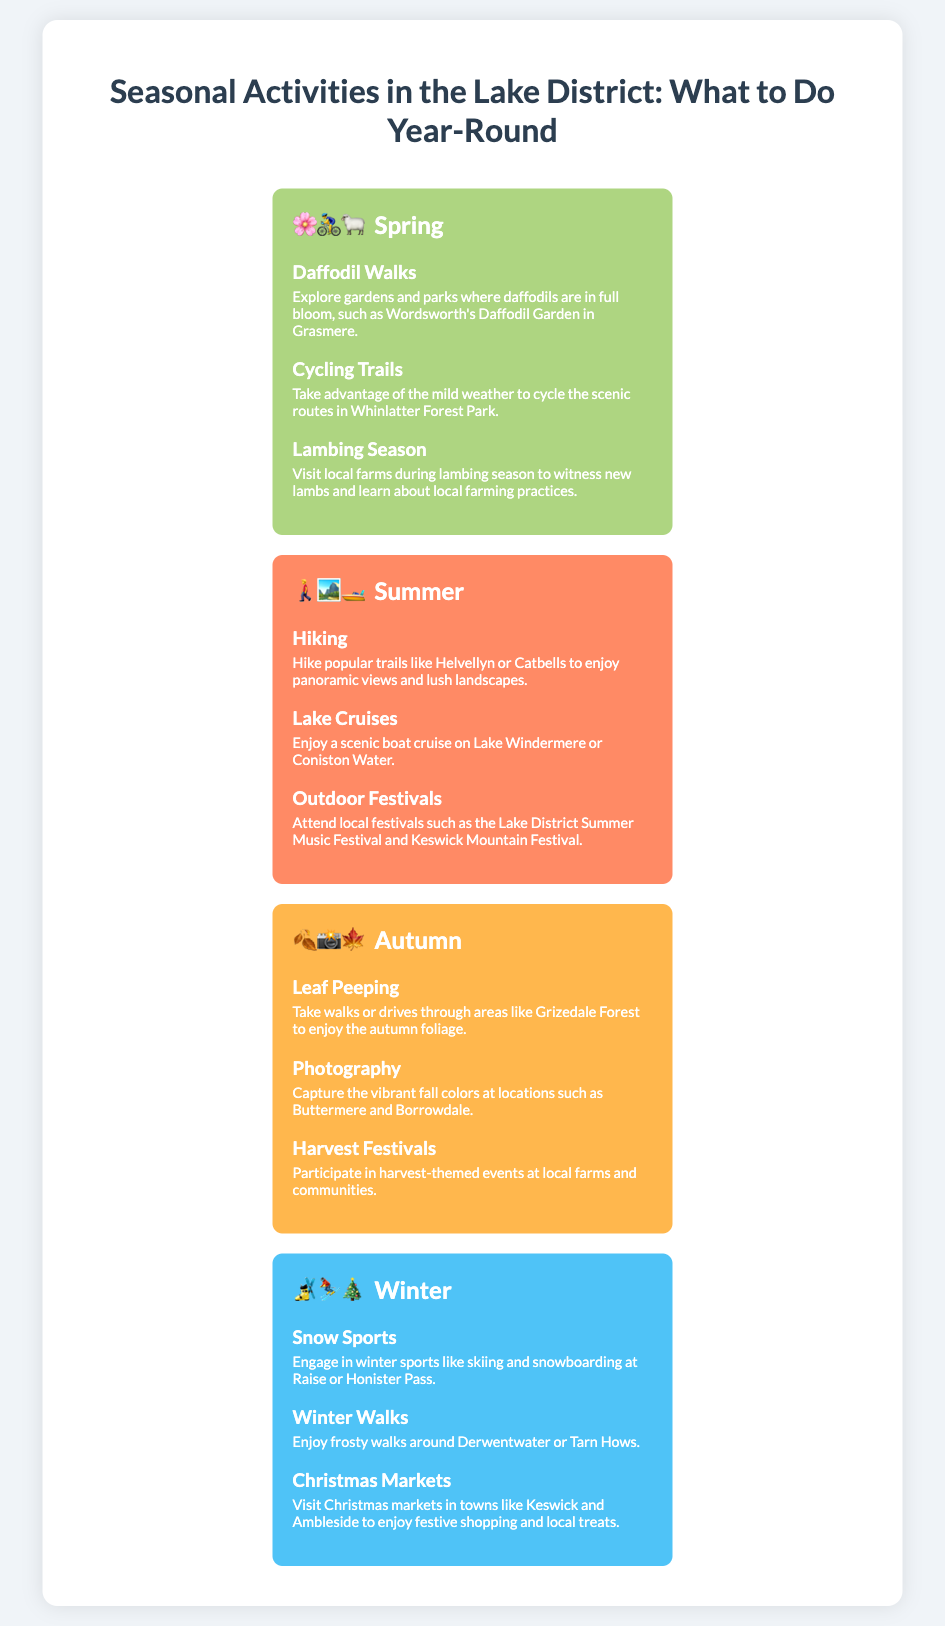What activities can you do in spring? The activities listed for spring include Daffodil Walks, Cycling Trails, and Lambing Season.
Answer: Daffodil Walks, Cycling Trails, Lambing Season Which season features hiking as an activity? Hiking is highlighted as an activity during the summer season.
Answer: Summer What color represents autumn in the infographic? The background color representing autumn is a shade of orange (#FFB74D).
Answer: Orange How many activities are listed for winter? There are three activities listed for winter: Snow Sports, Winter Walks, and Christmas Markets.
Answer: Three Which festival can you attend in summer? The activities mention attending the Lake District Summer Music Festival as a summer event.
Answer: Lake District Summer Music Festival What type of sports can be engaged in during winter? The document mentions snow sports in winter including skiing and snowboarding.
Answer: Snow sports What is the main theme of the autumn activities? The autumn activities focus on enjoying fall colors and harvest events, primarily through photography and leaf peeping.
Answer: Fall colors and harvest events What is the title of the infographic? The title provided at the top of the document outlines the seasonal activities available throughout the year in the Lake District.
Answer: Seasonal Activities in the Lake District: What to Do Year-Round 